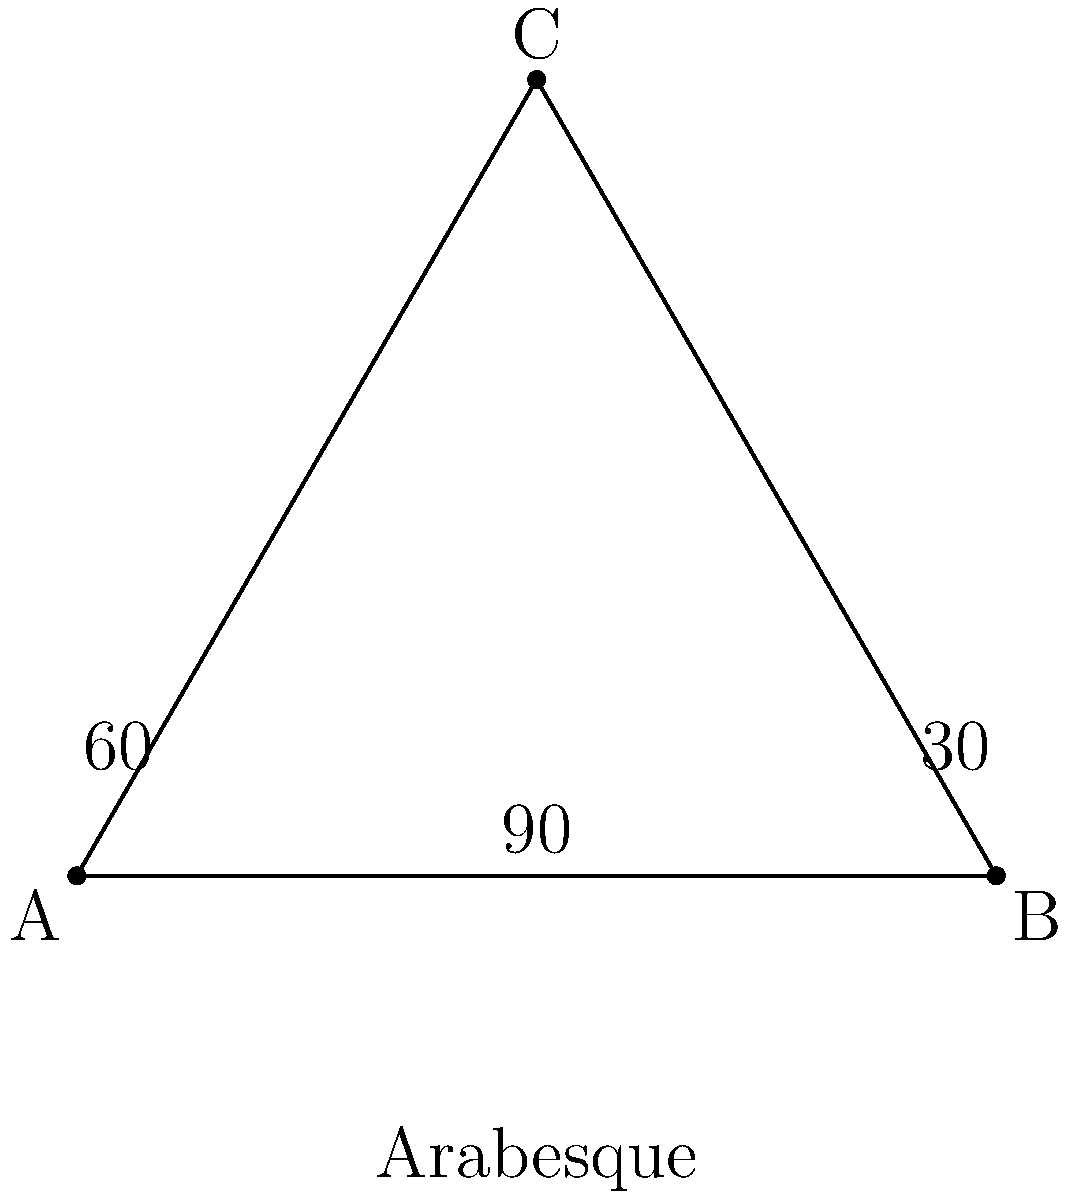In a perfect arabesque position, the dancer's standing leg forms a right angle with the floor, while the working leg is extended behind at a 60-degree angle from the vertical. What is the angle between the dancer's legs in this position? To find the angle between the dancer's legs in the arabesque position, we can follow these steps:

1. Identify the given information:
   - The standing leg forms a 90-degree angle with the floor (right angle)
   - The working leg is extended at a 60-degree angle from the vertical

2. Recognize that the vertical line (standing leg) and the floor form two of the three angles in a right triangle.

3. The third angle of this right triangle is formed by the working leg and the floor.

4. In a right triangle, the sum of all angles is 180 degrees:
   $90^\circ + 60^\circ + x = 180^\circ$
   Where $x$ is the angle between the working leg and the floor.

5. Solve for $x$:
   $x = 180^\circ - 90^\circ - 60^\circ = 30^\circ$

6. The angle we're looking for is between the standing leg (vertical) and the working leg.
   This angle is the complement of the 30-degree angle we just found.

7. Calculate the complement:
   $90^\circ - 30^\circ = 60^\circ$

Therefore, the angle between the dancer's legs in this arabesque position is 60 degrees.
Answer: $60^\circ$ 